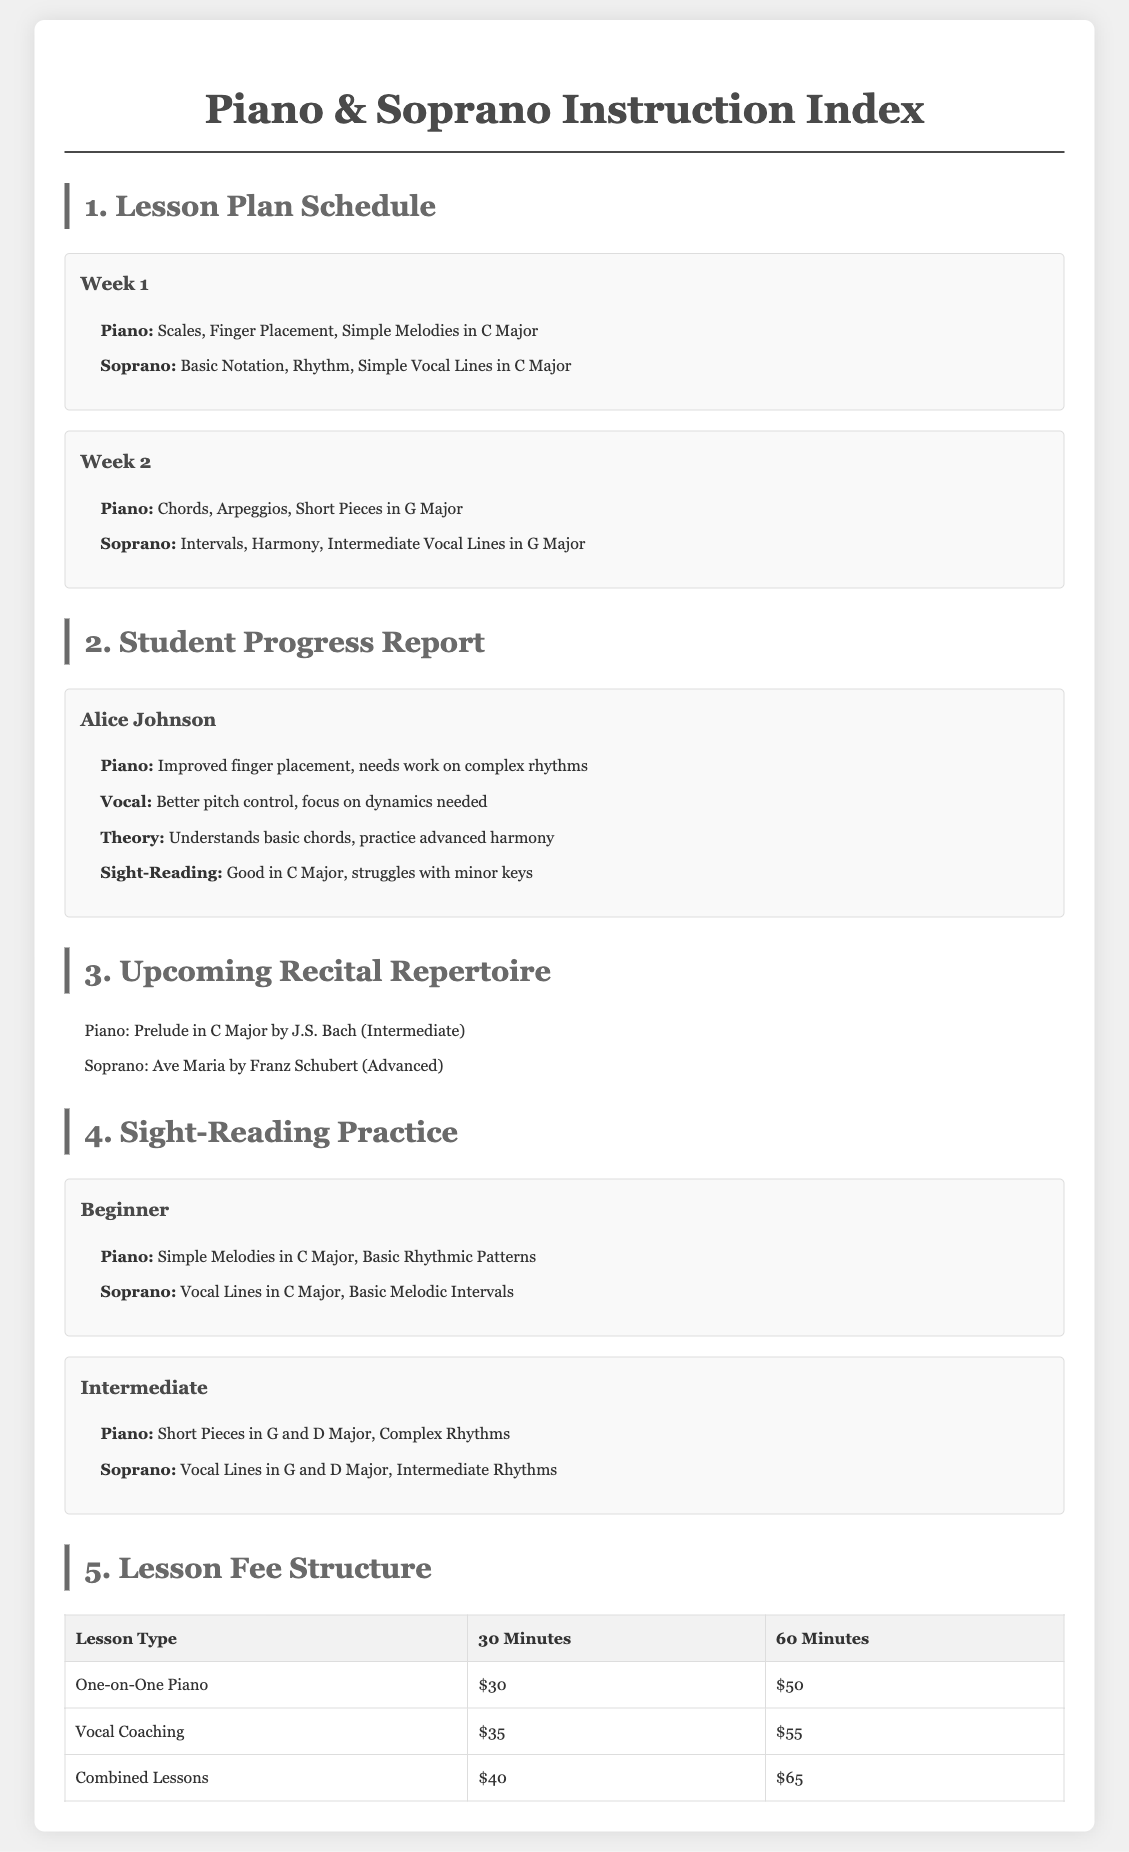What are the topics covered in Week 1 for piano? Week 1 for piano covers Scales, Finger Placement, Simple Melodies in C Major.
Answer: Scales, Finger Placement, Simple Melodies in C Major Who is mentioned in the Student Progress Report? The Student Progress Report includes the name of Alice Johnson as a student.
Answer: Alice Johnson What is the fee for a 60-minute vocal coaching lesson? The document lists the fee for a 60-minute vocal coaching lesson.
Answer: $55 What piece is selected for the upcoming soprano repertoire? The document specifies which piece is chosen for the soprano repertoire in the upcoming recital.
Answer: Ave Maria by Franz Schubert Which skill levels are included in the Sight-Reading Practice section? The Sight-Reading Practice section includes different skill levels identified in the document.
Answer: Beginner, Intermediate What does Alice need to focus on for vocals according to her progress report? The progress report indicates areas where Alice needs improvement in her vocal skills.
Answer: Focus on dynamics needed What is the price for combined lessons lasting 30 minutes? The document clearly states the price for combined lessons lasting half an hour.
Answer: $40 What is the main goal of Theory in Alice's progress report? The document specifies Alice's understanding and goal in music theory.
Answer: Practice advanced harmony 